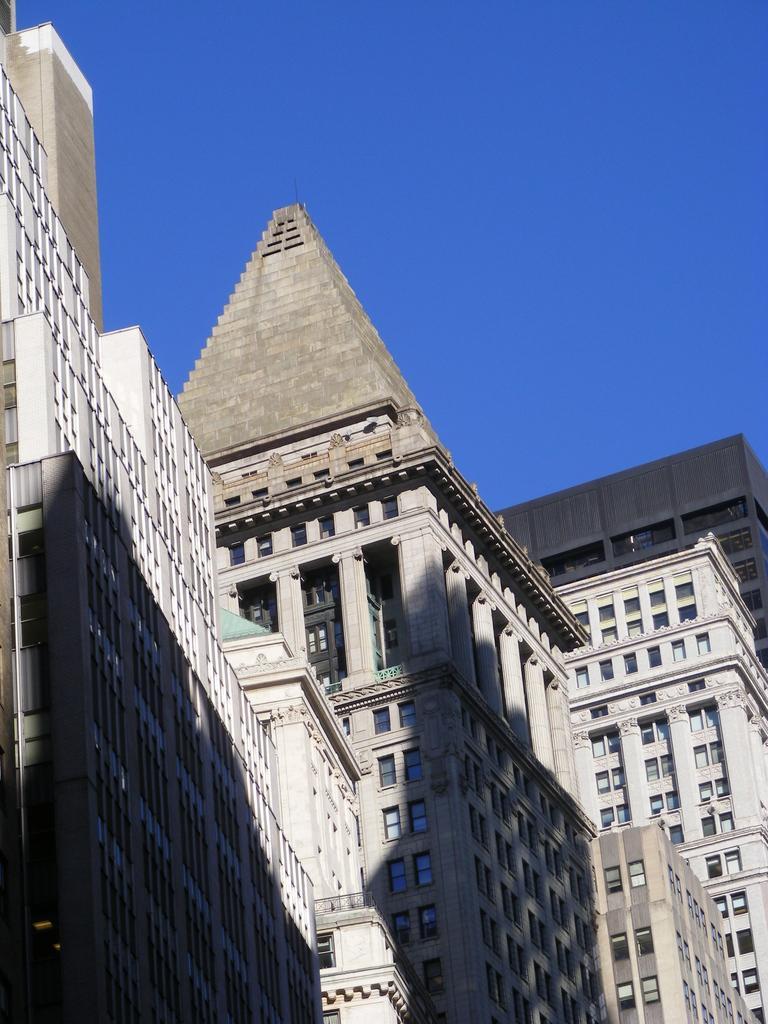How would you summarize this image in a sentence or two? In this picture we can see buildings, there is the sky at the top of the picture, we can see glass windows of these buildings. 